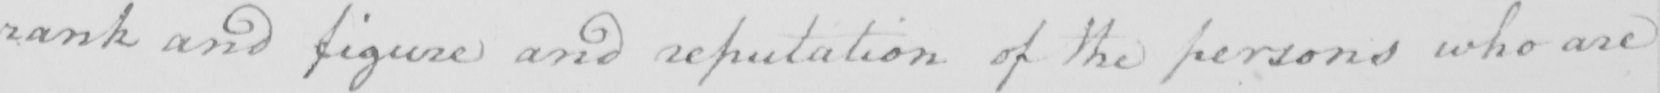What does this handwritten line say? rank and figure and reputation of the persons who are 